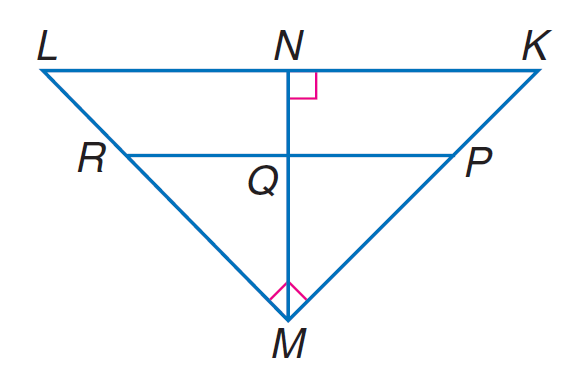Answer the mathemtical geometry problem and directly provide the correct option letter.
Question: If P R \parallel K L, K N = 9, L N = 16, P M = 2 K P, find M R.
Choices: A: 12 B: 26 / 2 C: 40 / 3 D: 14 C 